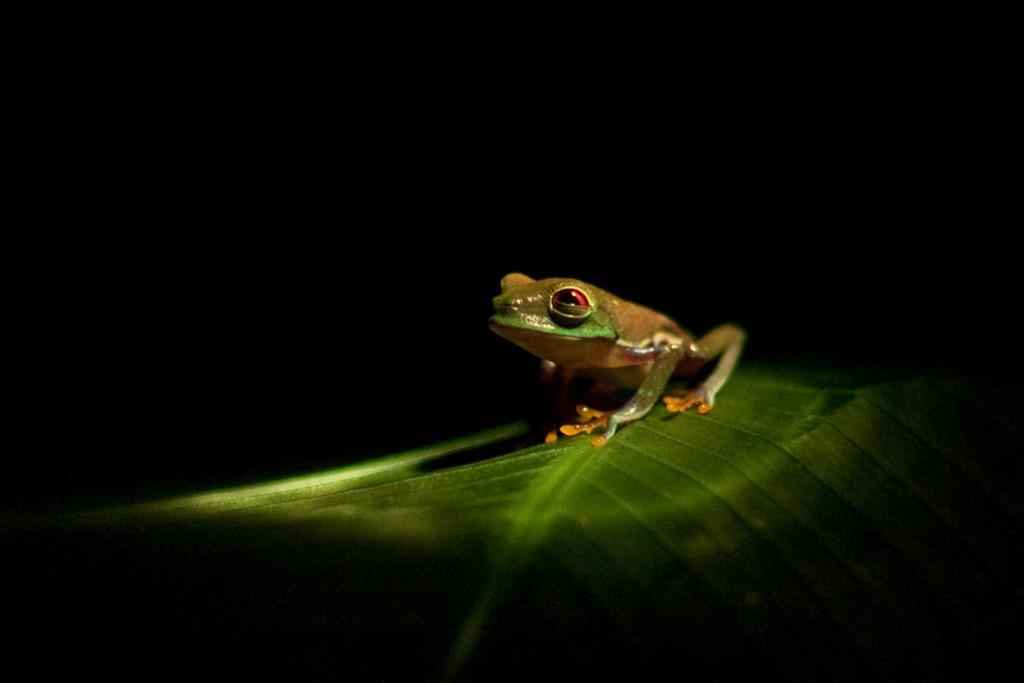Please provide a concise description of this image. In this image we can see a frog on a leaf. There is a black background. 